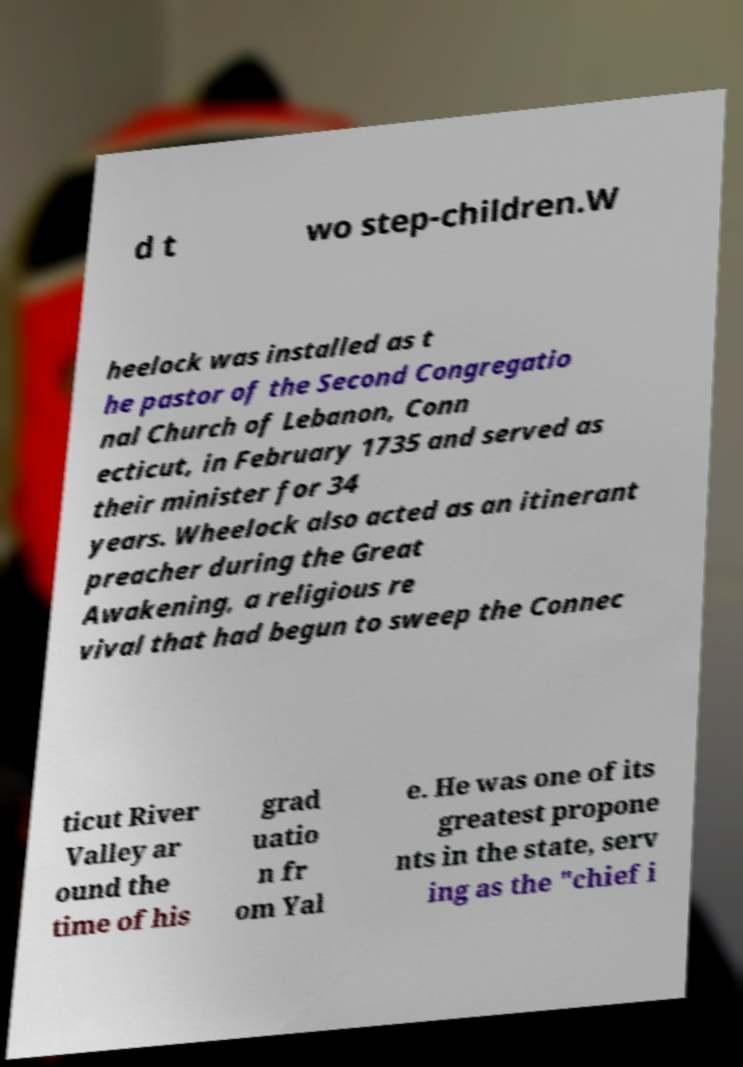Please identify and transcribe the text found in this image. d t wo step-children.W heelock was installed as t he pastor of the Second Congregatio nal Church of Lebanon, Conn ecticut, in February 1735 and served as their minister for 34 years. Wheelock also acted as an itinerant preacher during the Great Awakening, a religious re vival that had begun to sweep the Connec ticut River Valley ar ound the time of his grad uatio n fr om Yal e. He was one of its greatest propone nts in the state, serv ing as the "chief i 